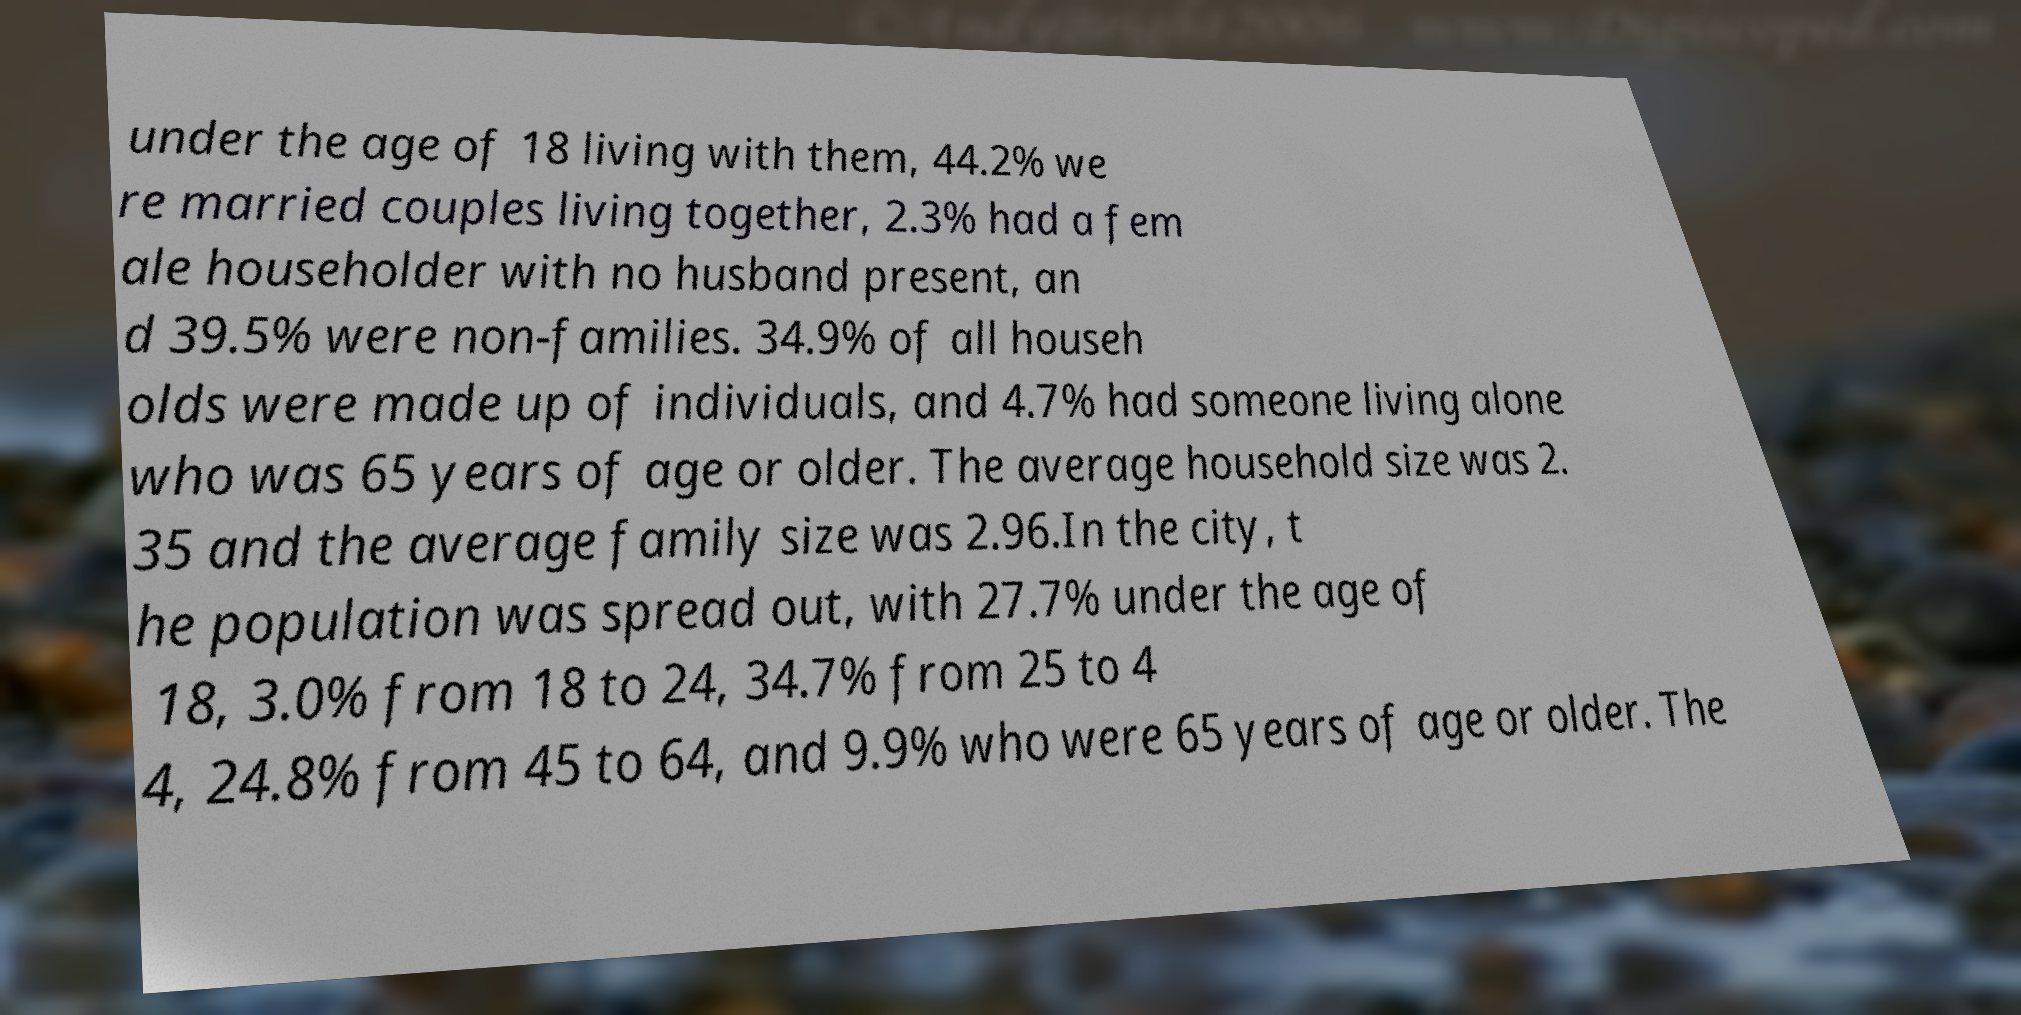Can you accurately transcribe the text from the provided image for me? under the age of 18 living with them, 44.2% we re married couples living together, 2.3% had a fem ale householder with no husband present, an d 39.5% were non-families. 34.9% of all househ olds were made up of individuals, and 4.7% had someone living alone who was 65 years of age or older. The average household size was 2. 35 and the average family size was 2.96.In the city, t he population was spread out, with 27.7% under the age of 18, 3.0% from 18 to 24, 34.7% from 25 to 4 4, 24.8% from 45 to 64, and 9.9% who were 65 years of age or older. The 